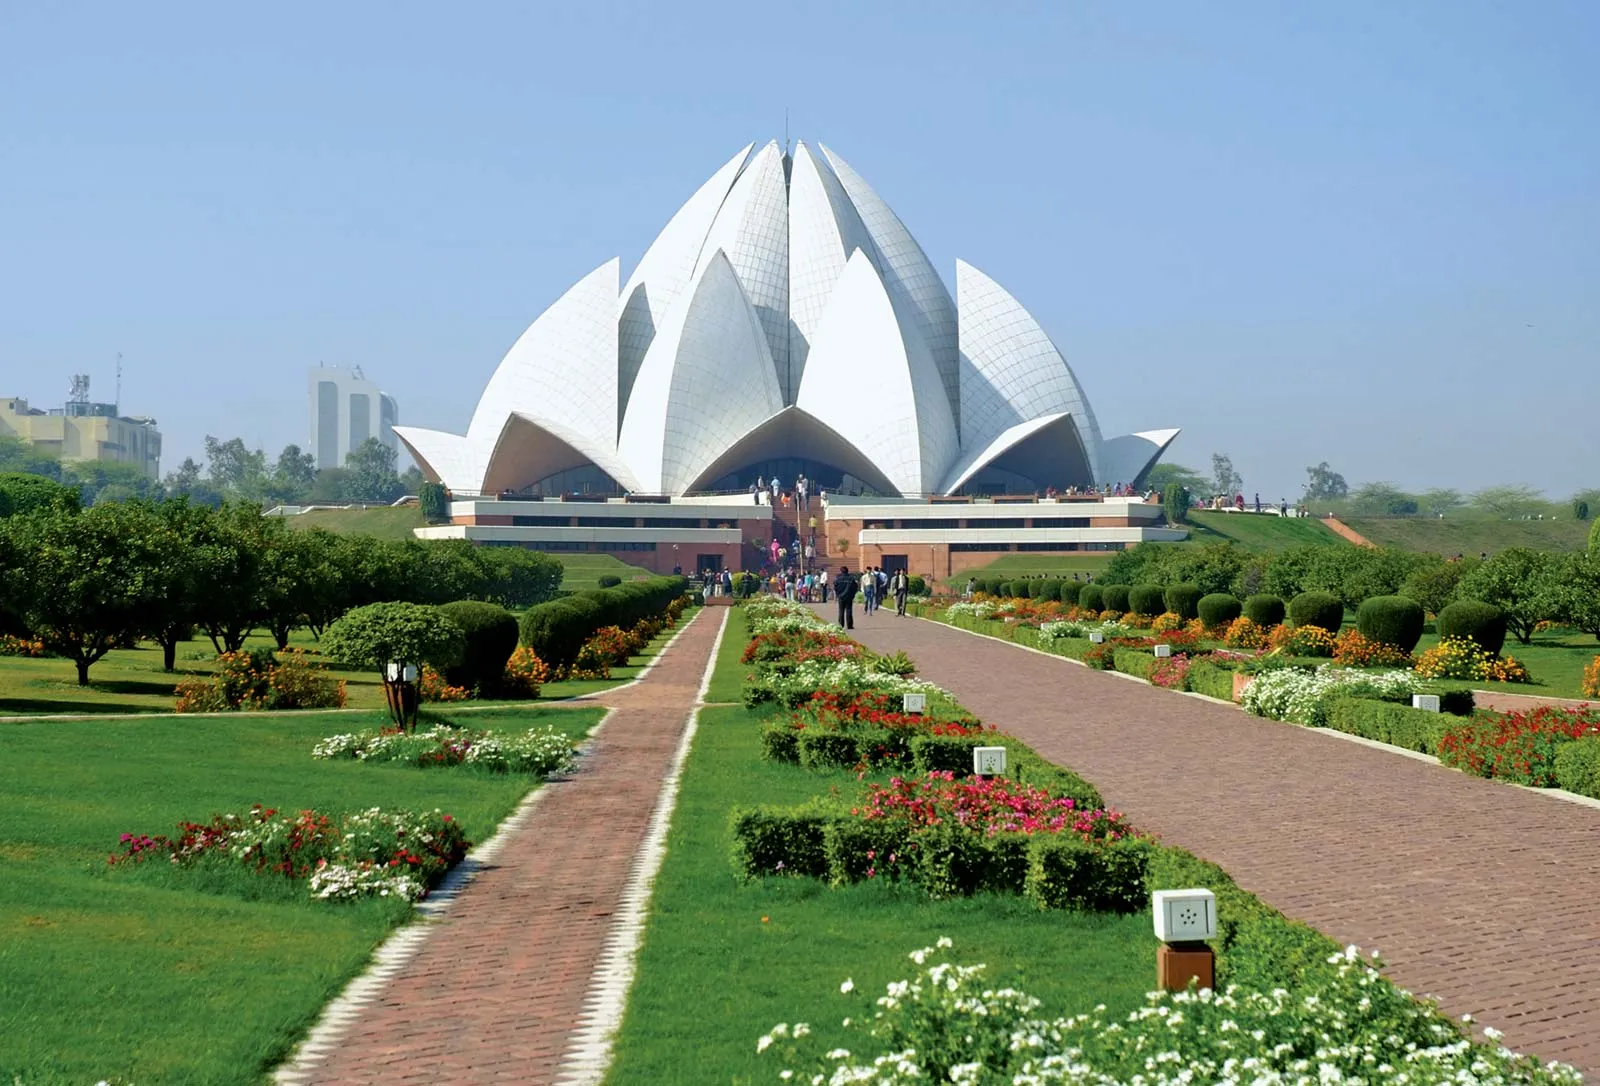What do you think is going on in this snapshot? The image shows the Lotus Temple, a prime example of architectural beauty and spiritual significance in New Delhi, India. Designed as a gigantic lotus flower, this Bahá'í House of Worship is famed for its tranquil environment and the unity it symbolizes among all religions. Its construction in pristine white marble and the surrounding verdant gardens dotted with vibrant blooms create a serene retreat in the bustling city. The temple's design, featuring 27 free-standing marble-clad 'petals' arranged in clusters, allows natural light to filter into the prayer hall, creating a celestial ambiance. This snapshot captures the essence of peace and spirituality that the Lotus Temple aims to embody, with visitors meandering through the lush gardens or pausing in quiet reflection. 